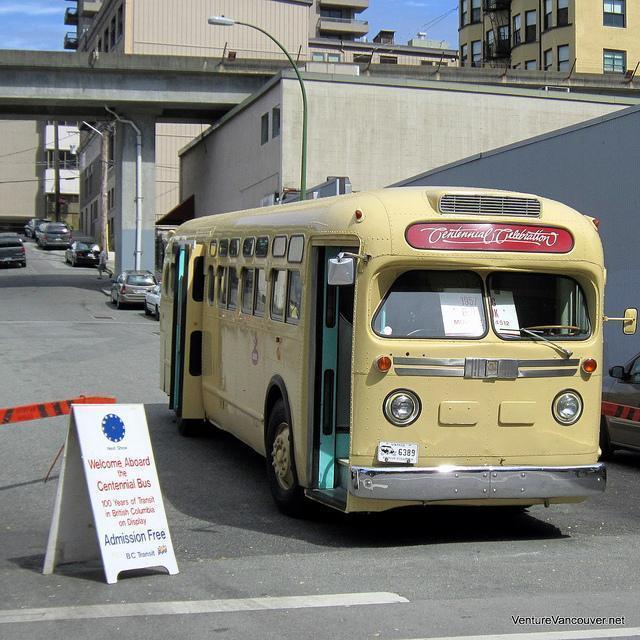This bus is part of what?
Indicate the correct response and explain using: 'Answer: answer
Rationale: rationale.'
Options: Reduced rides, sale, commute, exhibition. Answer: exhibition.
Rationale: This bus is part of a bus exhibition as is read from the sign. 